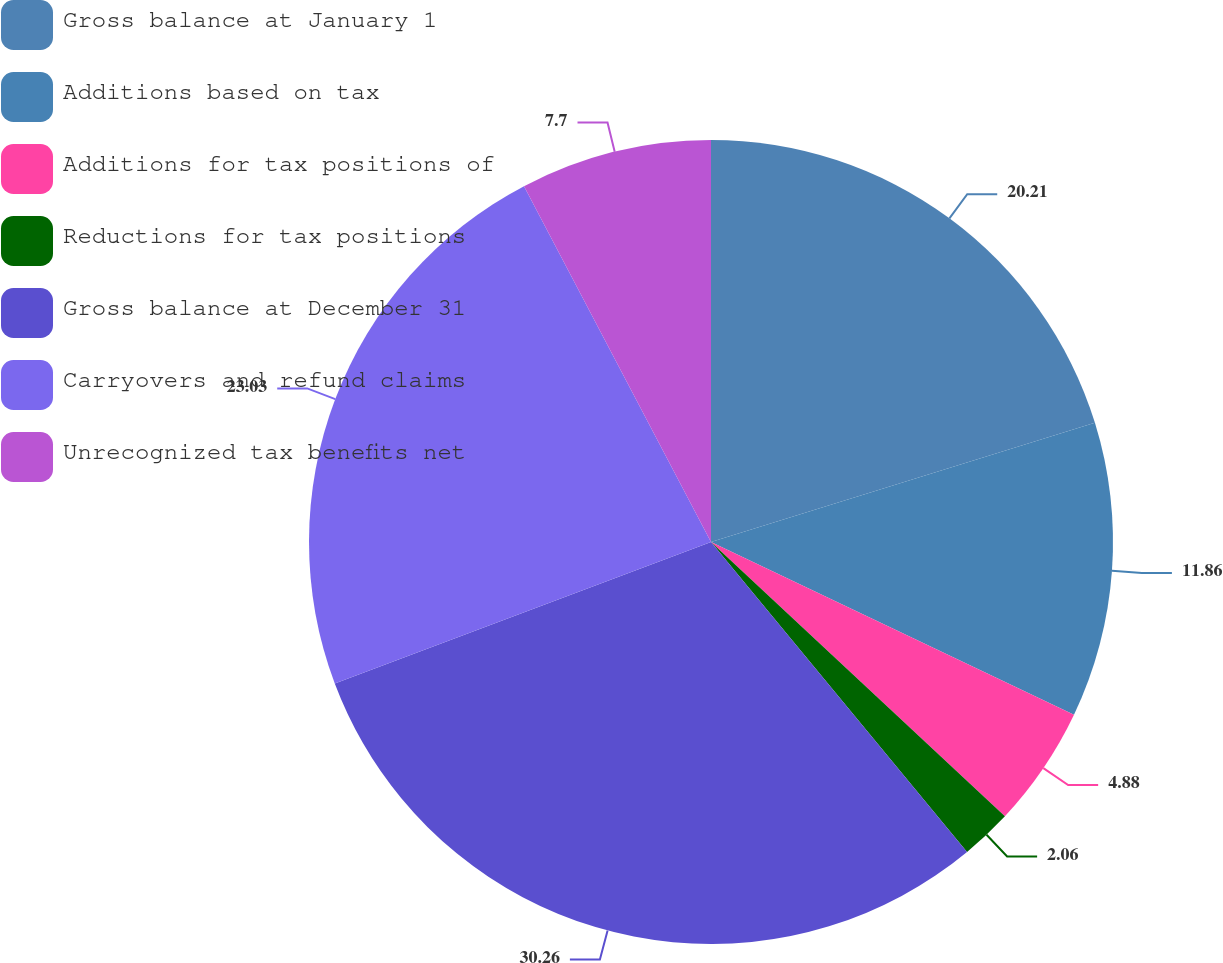<chart> <loc_0><loc_0><loc_500><loc_500><pie_chart><fcel>Gross balance at January 1<fcel>Additions based on tax<fcel>Additions for tax positions of<fcel>Reductions for tax positions<fcel>Gross balance at December 31<fcel>Carryovers and refund claims<fcel>Unrecognized tax benefits net<nl><fcel>20.21%<fcel>11.86%<fcel>4.88%<fcel>2.06%<fcel>30.26%<fcel>23.03%<fcel>7.7%<nl></chart> 